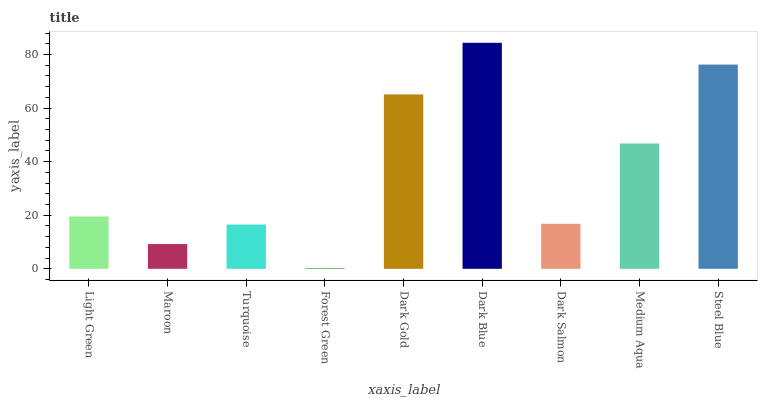Is Forest Green the minimum?
Answer yes or no. Yes. Is Dark Blue the maximum?
Answer yes or no. Yes. Is Maroon the minimum?
Answer yes or no. No. Is Maroon the maximum?
Answer yes or no. No. Is Light Green greater than Maroon?
Answer yes or no. Yes. Is Maroon less than Light Green?
Answer yes or no. Yes. Is Maroon greater than Light Green?
Answer yes or no. No. Is Light Green less than Maroon?
Answer yes or no. No. Is Light Green the high median?
Answer yes or no. Yes. Is Light Green the low median?
Answer yes or no. Yes. Is Maroon the high median?
Answer yes or no. No. Is Medium Aqua the low median?
Answer yes or no. No. 